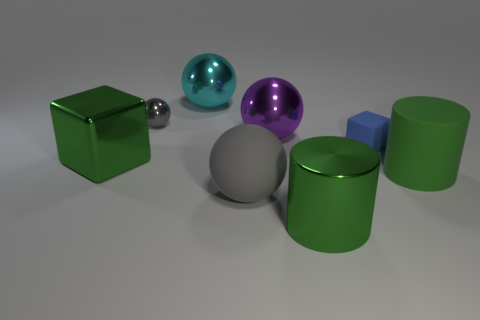What is the size of the object that is the same color as the small shiny sphere?
Offer a very short reply. Large. There is a small object that is right of the big cyan shiny ball; what is its color?
Keep it short and to the point. Blue. How many matte things are large cyan objects or big gray balls?
Ensure brevity in your answer.  1. What shape is the matte object that is the same color as the metal cylinder?
Keep it short and to the point. Cylinder. How many green metal cylinders have the same size as the green rubber cylinder?
Ensure brevity in your answer.  1. There is a big object that is on the right side of the large gray matte thing and in front of the rubber cylinder; what color is it?
Your answer should be very brief. Green. What number of things are big rubber cylinders or big cylinders?
Keep it short and to the point. 2. How many small things are gray matte balls or green metallic cylinders?
Ensure brevity in your answer.  0. Is there any other thing of the same color as the tiny metal ball?
Provide a succinct answer. Yes. There is a ball that is both left of the big purple metal object and in front of the gray metal ball; how big is it?
Your response must be concise. Large. 